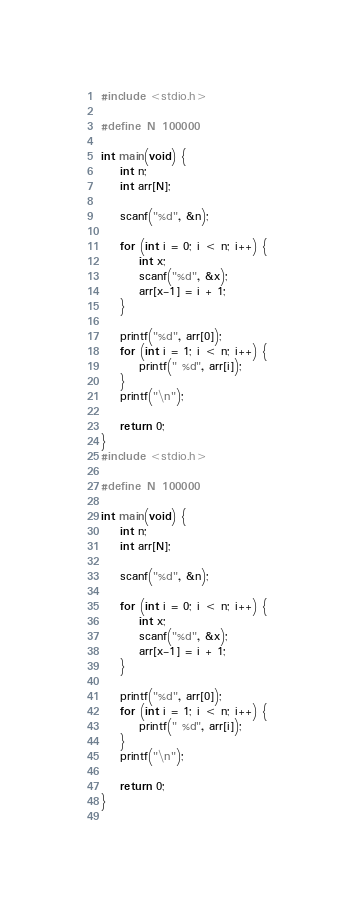<code> <loc_0><loc_0><loc_500><loc_500><_C_>#include <stdio.h>
 
#define N 100000
 
int main(void) {
    int n;
    int arr[N];
 
    scanf("%d", &n);
 
    for (int i = 0; i < n; i++) {
        int x;
        scanf("%d", &x);
        arr[x-1] = i + 1;
    }
 
    printf("%d", arr[0]);
    for (int i = 1; i < n; i++) {
        printf(" %d", arr[i]);
    }
    printf("\n");
 
    return 0;
}
#include <stdio.h>

#define N 100000

int main(void) {
    int n;
    int arr[N];

    scanf("%d", &n);

    for (int i = 0; i < n; i++) {
        int x;
        scanf("%d", &x);
        arr[x-1] = i + 1;
    }

    printf("%d", arr[0]);
    for (int i = 1; i < n; i++) {
        printf(" %d", arr[i]);
    }
    printf("\n");

    return 0;
}
	</code> 